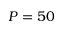<formula> <loc_0><loc_0><loc_500><loc_500>P = 5 0</formula> 